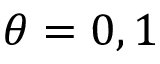<formula> <loc_0><loc_0><loc_500><loc_500>\theta = 0 , 1</formula> 